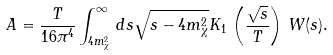Convert formula to latex. <formula><loc_0><loc_0><loc_500><loc_500>A = \frac { T } { 1 6 \pi ^ { 4 } } \int _ { 4 m _ { \chi } ^ { 2 } } ^ { \infty } \, d s \sqrt { s - 4 m _ { \chi } ^ { 2 } } K _ { 1 } \, \left ( \frac { \sqrt { s } } { T } \right ) \, W ( s ) .</formula> 